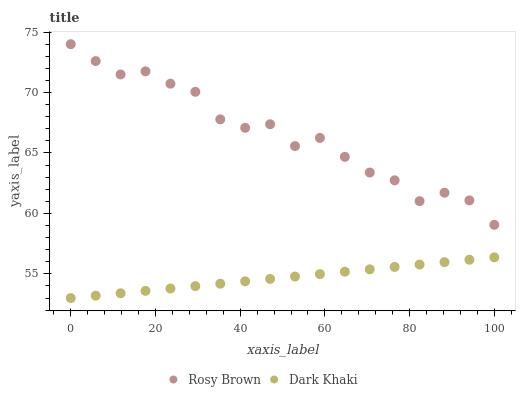Does Dark Khaki have the minimum area under the curve?
Answer yes or no. Yes. Does Rosy Brown have the maximum area under the curve?
Answer yes or no. Yes. Does Rosy Brown have the minimum area under the curve?
Answer yes or no. No. Is Dark Khaki the smoothest?
Answer yes or no. Yes. Is Rosy Brown the roughest?
Answer yes or no. Yes. Is Rosy Brown the smoothest?
Answer yes or no. No. Does Dark Khaki have the lowest value?
Answer yes or no. Yes. Does Rosy Brown have the lowest value?
Answer yes or no. No. Does Rosy Brown have the highest value?
Answer yes or no. Yes. Is Dark Khaki less than Rosy Brown?
Answer yes or no. Yes. Is Rosy Brown greater than Dark Khaki?
Answer yes or no. Yes. Does Dark Khaki intersect Rosy Brown?
Answer yes or no. No. 